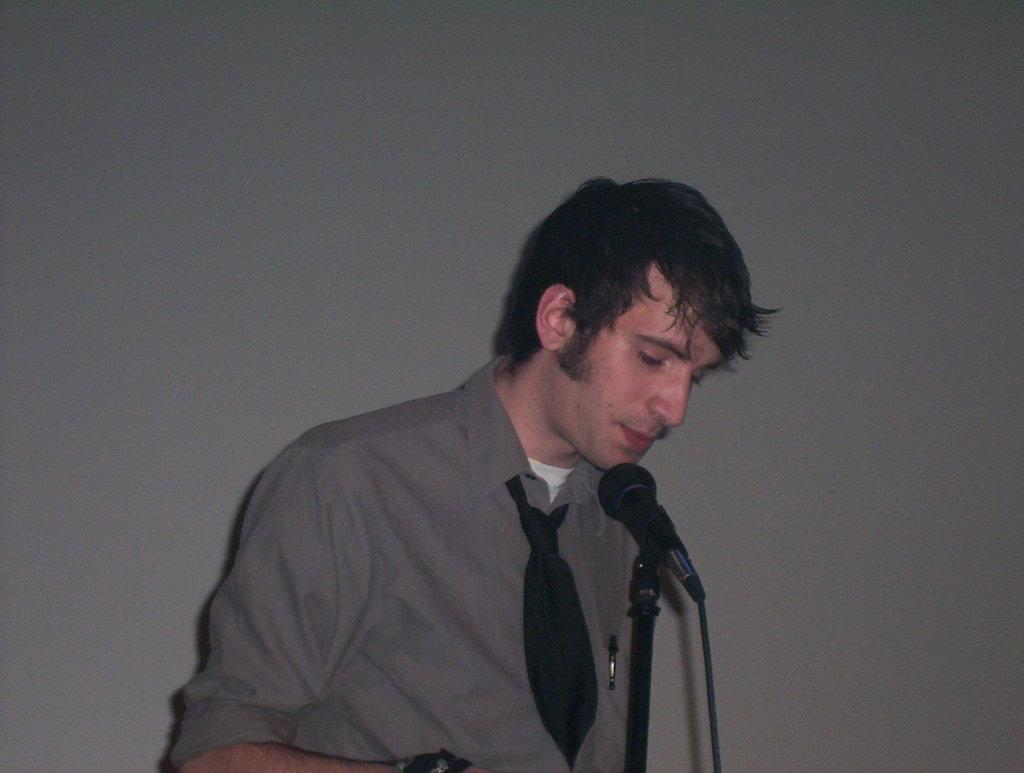Who is the main subject in the image? There is a man in the image. What is the man wearing? The man is wearing a shirt and a black tie. What object is in front of the man? There is a microphone (mic) in front of the man. How many pigs can be seen on the desk in the image? There is no desk or pig present in the image. 